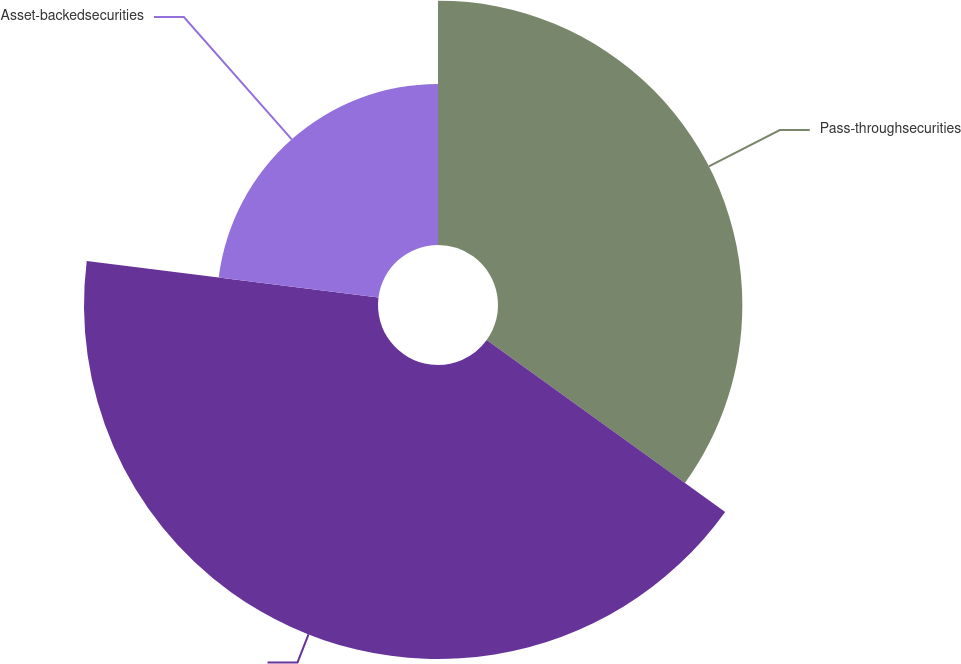<chart> <loc_0><loc_0><loc_500><loc_500><pie_chart><fcel>Pass-throughsecurities<fcel>Unnamed: 1<fcel>Asset-backedsecurities<nl><fcel>34.94%<fcel>42.04%<fcel>23.02%<nl></chart> 